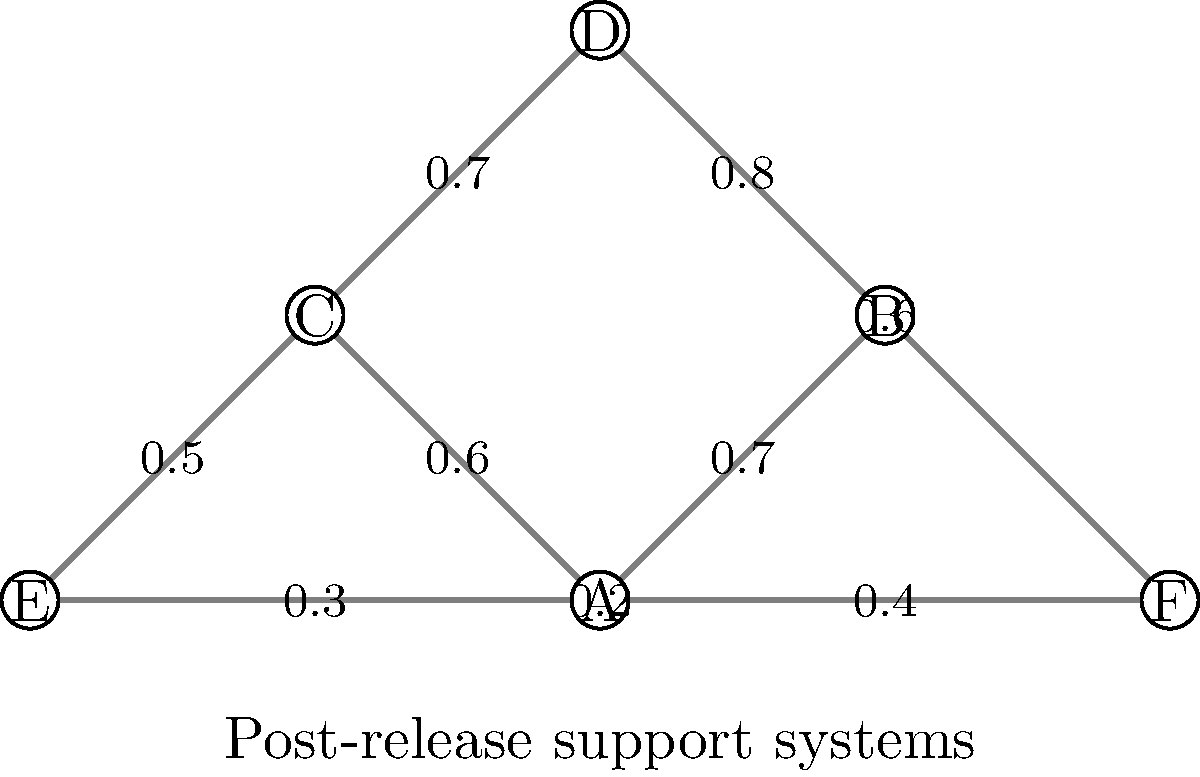In the weighted graph representing the correlation between post-release support systems and recidivism rates, what is the total weight of the shortest path from node A to node D? To find the shortest path from node A to node D, we need to consider all possible paths and their total weights:

1. A → B → D: 0.7 + 0.8 = 1.5
2. A → C → D: 0.6 + 0.7 = 1.3
3. A → F → D: 0.4 + 0.6 = 1.0

Step-by-step calculation of the shortest path:

1. Start at node A
2. Compare the paths:
   - Path through B: 1.5
   - Path through C: 1.3
   - Path through F: 1.0
3. The path with the lowest total weight is A → F → D

Therefore, the shortest path from A to D is through F, with a total weight of 1.0.

This result suggests that individuals with access to the support system represented by node F have the lowest likelihood of recidivism when transitioning to the situation represented by node D.
Answer: 1.0 